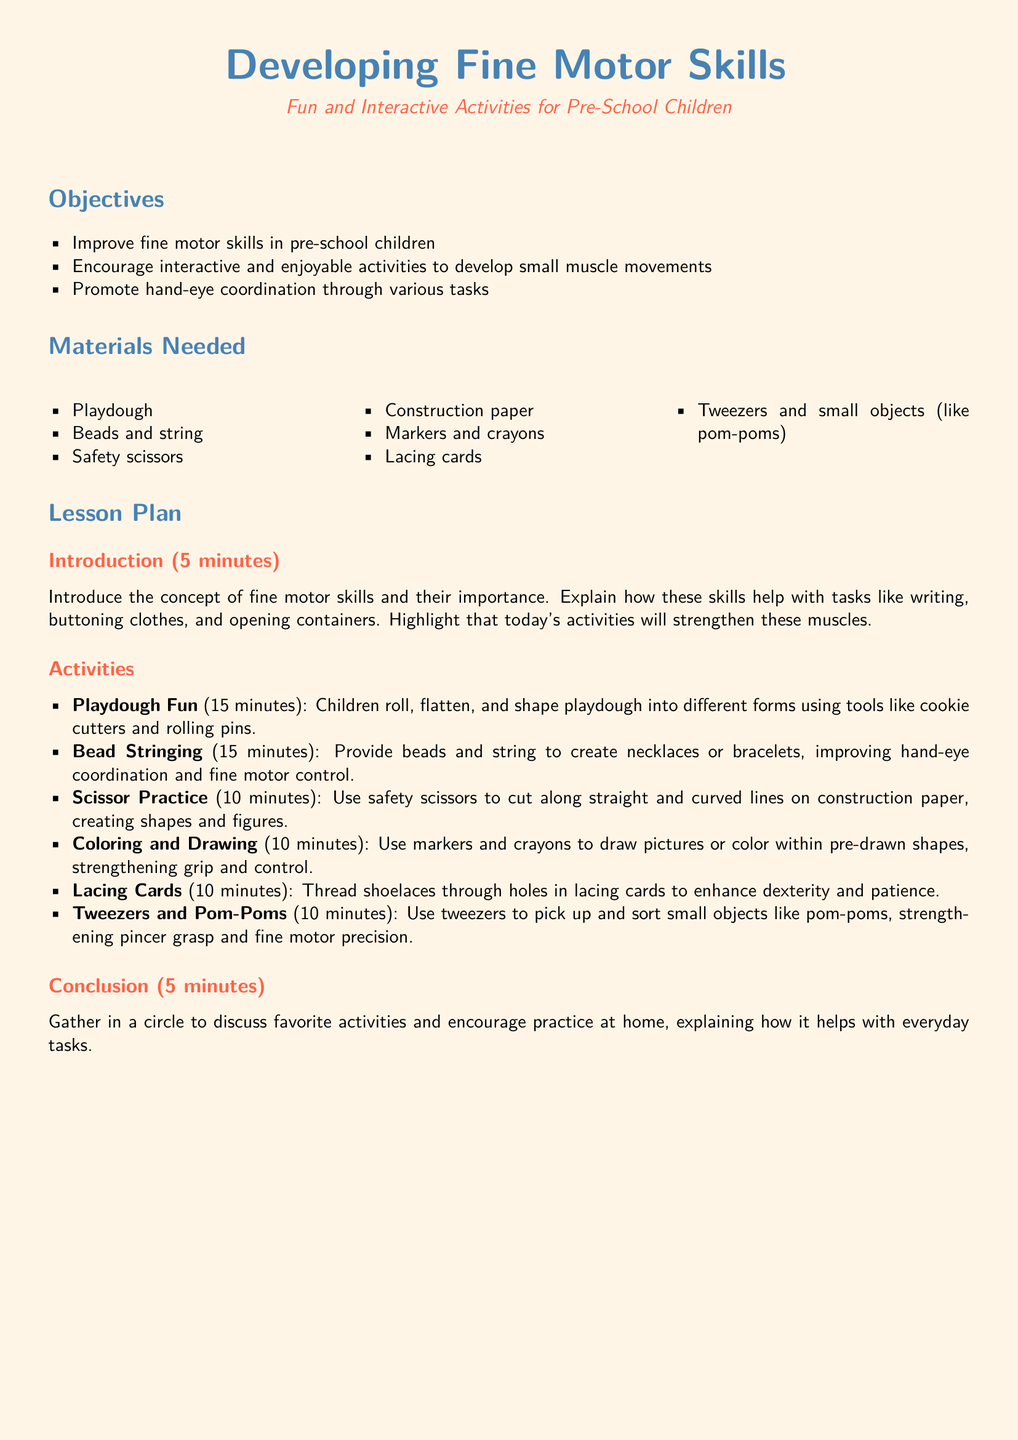What is the objective of the lesson? The objective is to improve fine motor skills in pre-school children, focusing on small muscle movements.
Answer: Improve fine motor skills How long is the 'Playdough Fun' activity? The duration of the 'Playdough Fun' activity is specified in the lesson plan.
Answer: 15 minutes What materials are needed for 'Bead Stringing'? The materials required for 'Bead Stringing' include beads and string, as outlined in the materials section.
Answer: Beads and string What type of scissors are used in the lesson? The lesson specifies the type of scissors to be used for safety during activities.
Answer: Safety scissors What skill is enhanced through lacing cards? The activity of using lacing cards develops a particular skill mentioned in the lesson plan.
Answer: Dexterity How many activities are listed in the lesson plan? The total number of activities can be counted from the activities section in the lesson plan.
Answer: 6 activities What is the main focus of the conclusion? The conclusion encourages a particular practice related to activities discussed in the lesson.
Answer: Practice at home What is the color of the page background in the document? The color of the background page is defined in the document's formatting details.
Answer: Light peach 